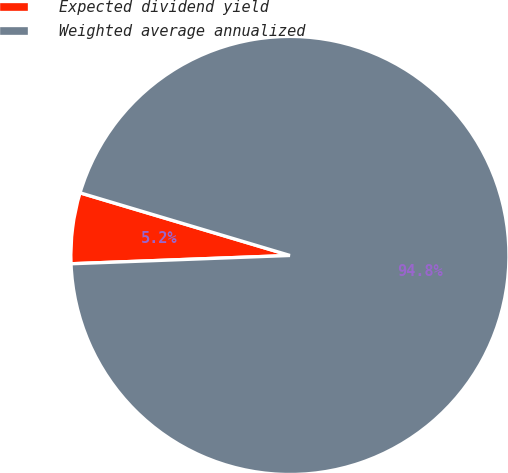<chart> <loc_0><loc_0><loc_500><loc_500><pie_chart><fcel>Expected dividend yield<fcel>Weighted average annualized<nl><fcel>5.22%<fcel>94.78%<nl></chart> 